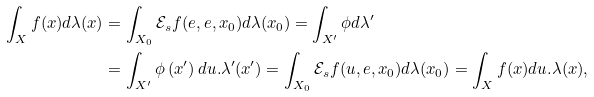Convert formula to latex. <formula><loc_0><loc_0><loc_500><loc_500>\int _ { X } f ( x ) d \lambda ( x ) & = \int _ { X _ { 0 } } \mathcal { E } _ { s } f ( e , e , x _ { 0 } ) d \lambda ( x _ { 0 } ) = \int _ { X ^ { \prime } } \phi d \lambda ^ { \prime } \\ & = \int _ { X ^ { \prime } } \phi \left ( x ^ { \prime } \right ) d u . \lambda ^ { \prime } ( x ^ { \prime } ) = \int _ { X _ { 0 } } \mathcal { E } _ { s } f ( u , e , x _ { 0 } ) d \lambda ( x _ { 0 } ) = \int _ { X } f ( x ) d u . \lambda ( x ) ,</formula> 